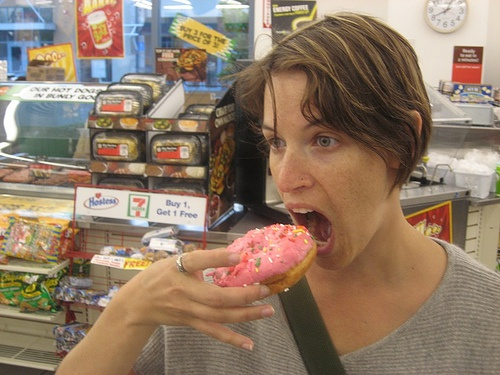Describe the objects in this image and their specific colors. I can see people in darkgray, gray, tan, and black tones, donut in darkgray, salmon, and brown tones, handbag in darkgray, black, maroon, and gray tones, and clock in darkgray, lightgray, and tan tones in this image. 